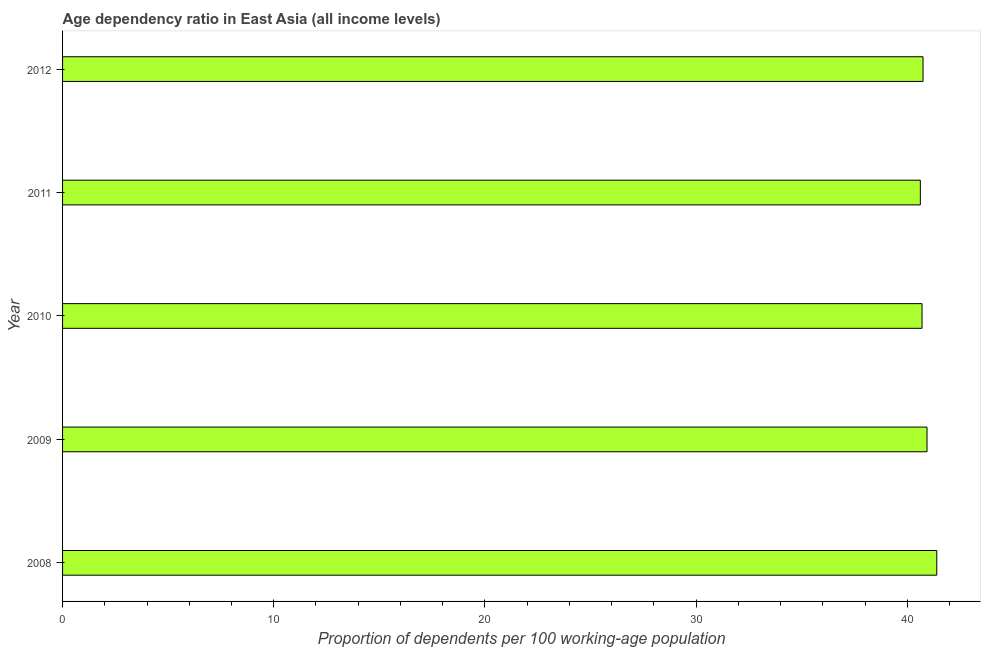Does the graph contain any zero values?
Ensure brevity in your answer.  No. Does the graph contain grids?
Your response must be concise. No. What is the title of the graph?
Offer a terse response. Age dependency ratio in East Asia (all income levels). What is the label or title of the X-axis?
Keep it short and to the point. Proportion of dependents per 100 working-age population. What is the label or title of the Y-axis?
Give a very brief answer. Year. What is the age dependency ratio in 2010?
Keep it short and to the point. 40.7. Across all years, what is the maximum age dependency ratio?
Keep it short and to the point. 41.4. Across all years, what is the minimum age dependency ratio?
Your response must be concise. 40.62. In which year was the age dependency ratio maximum?
Your response must be concise. 2008. What is the sum of the age dependency ratio?
Keep it short and to the point. 204.4. What is the difference between the age dependency ratio in 2009 and 2010?
Offer a terse response. 0.24. What is the average age dependency ratio per year?
Give a very brief answer. 40.88. What is the median age dependency ratio?
Offer a very short reply. 40.75. In how many years, is the age dependency ratio greater than 36 ?
Your answer should be compact. 5. Do a majority of the years between 2009 and 2011 (inclusive) have age dependency ratio greater than 30 ?
Your answer should be very brief. Yes. Is the age dependency ratio in 2008 less than that in 2011?
Your answer should be very brief. No. Is the difference between the age dependency ratio in 2008 and 2010 greater than the difference between any two years?
Keep it short and to the point. No. What is the difference between the highest and the second highest age dependency ratio?
Keep it short and to the point. 0.46. What is the difference between the highest and the lowest age dependency ratio?
Offer a very short reply. 0.78. Are all the bars in the graph horizontal?
Keep it short and to the point. Yes. How many years are there in the graph?
Provide a short and direct response. 5. Are the values on the major ticks of X-axis written in scientific E-notation?
Offer a very short reply. No. What is the Proportion of dependents per 100 working-age population of 2008?
Your response must be concise. 41.4. What is the Proportion of dependents per 100 working-age population in 2009?
Keep it short and to the point. 40.94. What is the Proportion of dependents per 100 working-age population in 2010?
Make the answer very short. 40.7. What is the Proportion of dependents per 100 working-age population of 2011?
Offer a terse response. 40.62. What is the Proportion of dependents per 100 working-age population in 2012?
Your answer should be compact. 40.75. What is the difference between the Proportion of dependents per 100 working-age population in 2008 and 2009?
Provide a short and direct response. 0.46. What is the difference between the Proportion of dependents per 100 working-age population in 2008 and 2010?
Keep it short and to the point. 0.7. What is the difference between the Proportion of dependents per 100 working-age population in 2008 and 2011?
Offer a terse response. 0.78. What is the difference between the Proportion of dependents per 100 working-age population in 2008 and 2012?
Offer a very short reply. 0.65. What is the difference between the Proportion of dependents per 100 working-age population in 2009 and 2010?
Make the answer very short. 0.24. What is the difference between the Proportion of dependents per 100 working-age population in 2009 and 2011?
Ensure brevity in your answer.  0.32. What is the difference between the Proportion of dependents per 100 working-age population in 2009 and 2012?
Your response must be concise. 0.19. What is the difference between the Proportion of dependents per 100 working-age population in 2010 and 2011?
Provide a succinct answer. 0.08. What is the difference between the Proportion of dependents per 100 working-age population in 2010 and 2012?
Provide a short and direct response. -0.05. What is the difference between the Proportion of dependents per 100 working-age population in 2011 and 2012?
Your response must be concise. -0.13. What is the ratio of the Proportion of dependents per 100 working-age population in 2008 to that in 2009?
Offer a terse response. 1.01. What is the ratio of the Proportion of dependents per 100 working-age population in 2008 to that in 2011?
Your answer should be very brief. 1.02. What is the ratio of the Proportion of dependents per 100 working-age population in 2010 to that in 2012?
Offer a terse response. 1. 